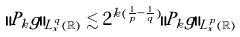<formula> <loc_0><loc_0><loc_500><loc_500>\| P _ { k } g \| _ { L _ { x } ^ { q } ( \mathbb { R } ) } \lesssim 2 ^ { k ( \frac { 1 } { p } - \frac { 1 } { q } ) } \| P _ { k } g \| _ { L _ { x } ^ { p } ( \mathbb { R } ) }</formula> 